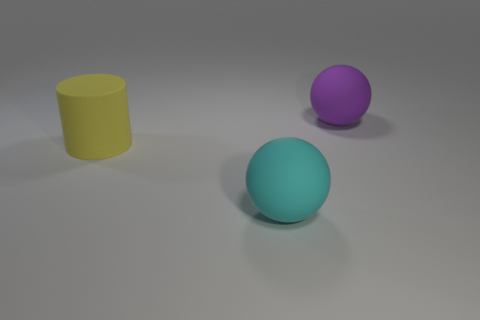What is the shape of the large cyan object that is to the left of the thing that is behind the yellow rubber cylinder?
Ensure brevity in your answer.  Sphere. Are there the same number of purple matte balls that are in front of the large purple rubber ball and green matte balls?
Your response must be concise. Yes. There is a big ball to the left of the rubber ball behind the large cyan ball that is left of the big purple object; what is it made of?
Your response must be concise. Rubber. Are there any cyan balls that have the same size as the cyan matte object?
Your answer should be very brief. No. What is the shape of the cyan object?
Ensure brevity in your answer.  Sphere. What number of cylinders are purple objects or big cyan metal objects?
Offer a very short reply. 0. Are there the same number of yellow cylinders that are right of the yellow thing and purple objects that are in front of the large cyan sphere?
Offer a terse response. Yes. There is a big matte sphere on the left side of the big matte thing that is on the right side of the large cyan ball; what number of rubber things are behind it?
Your answer should be compact. 2. There is a cylinder; is its color the same as the large matte ball that is behind the big cylinder?
Provide a succinct answer. No. Is the number of big rubber things that are on the right side of the large yellow matte object greater than the number of big things?
Ensure brevity in your answer.  No. 